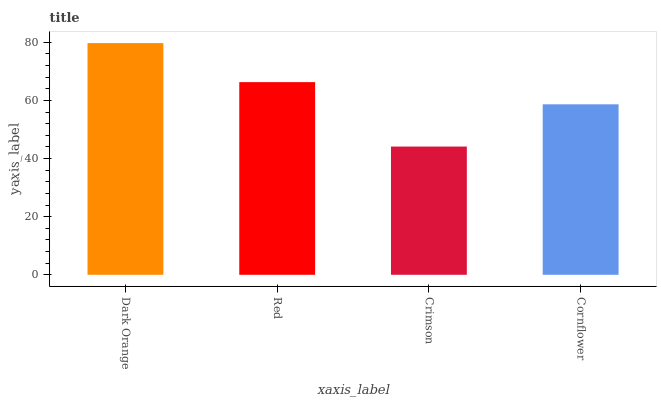Is Red the minimum?
Answer yes or no. No. Is Red the maximum?
Answer yes or no. No. Is Dark Orange greater than Red?
Answer yes or no. Yes. Is Red less than Dark Orange?
Answer yes or no. Yes. Is Red greater than Dark Orange?
Answer yes or no. No. Is Dark Orange less than Red?
Answer yes or no. No. Is Red the high median?
Answer yes or no. Yes. Is Cornflower the low median?
Answer yes or no. Yes. Is Cornflower the high median?
Answer yes or no. No. Is Crimson the low median?
Answer yes or no. No. 